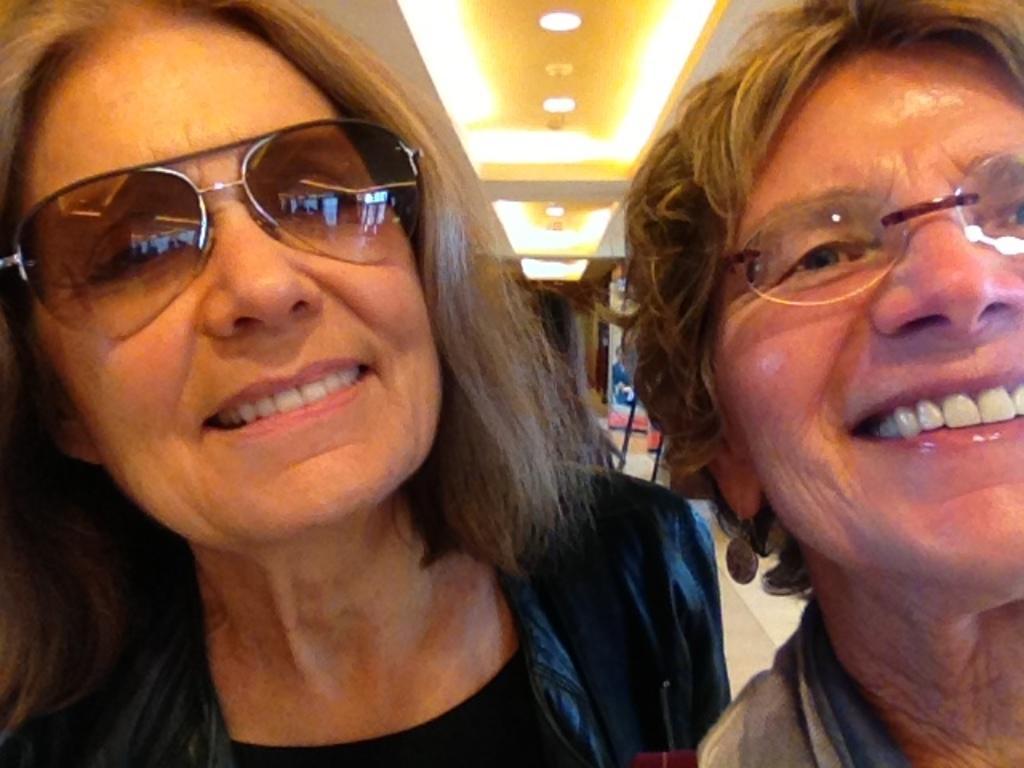How would you summarize this image in a sentence or two? In this image I can see two people with the dresses. In the background I can see the door and I can see the lights at the top. 